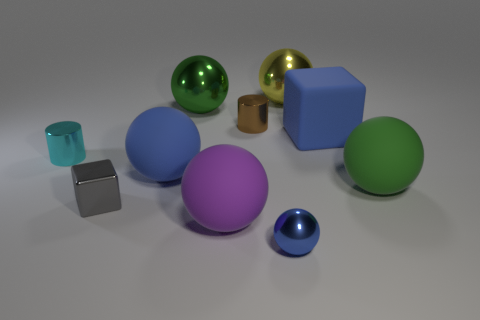How many other objects are there of the same color as the rubber cube?
Your response must be concise. 2. How many balls are green matte objects or yellow things?
Provide a short and direct response. 2. There is a metal cylinder on the right side of the tiny object on the left side of the gray block; what color is it?
Make the answer very short. Brown. The tiny brown shiny object has what shape?
Provide a short and direct response. Cylinder. There is a metallic sphere in front of the cyan cylinder; does it have the same size as the green metal ball?
Offer a terse response. No. Are there any large yellow things made of the same material as the cyan object?
Make the answer very short. Yes. What number of things are either objects that are in front of the brown metallic thing or tiny metallic blocks?
Offer a very short reply. 7. Is there a gray shiny object?
Your answer should be very brief. Yes. What is the shape of the blue thing that is both behind the gray object and on the left side of the big blue matte cube?
Offer a terse response. Sphere. There is a green ball that is to the right of the blue cube; how big is it?
Your response must be concise. Large. 